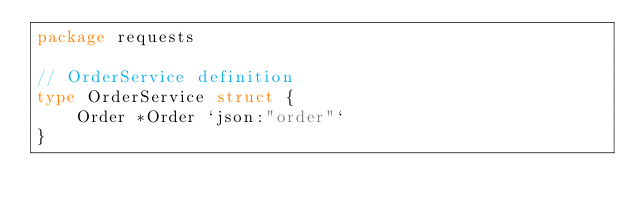<code> <loc_0><loc_0><loc_500><loc_500><_Go_>package requests

// OrderService definition
type OrderService struct {
	Order *Order `json:"order"`
}
</code> 